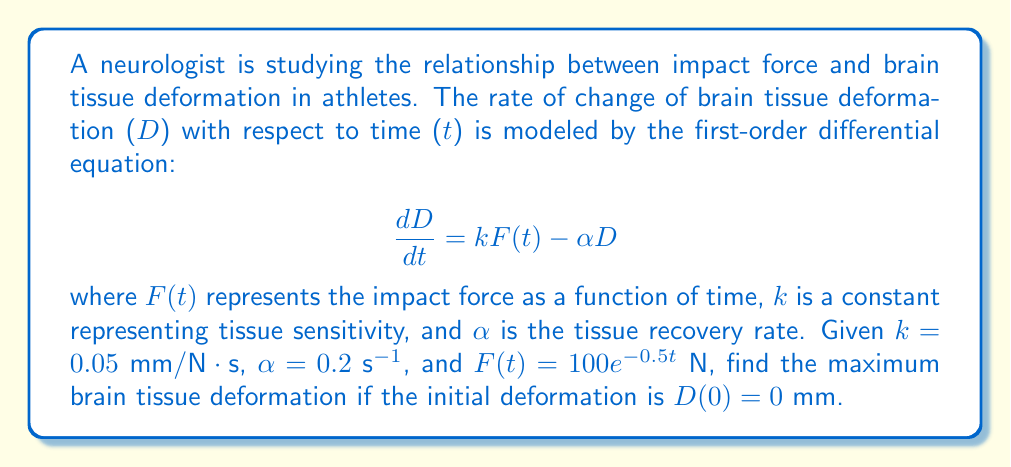Could you help me with this problem? To solve this problem, we need to follow these steps:

1) First, we need to solve the differential equation:

   $$\frac{dD}{dt} = kF(t) - \alpha D$$
   $$\frac{dD}{dt} = 0.05(100e^{-0.5t}) - 0.2D$$
   $$\frac{dD}{dt} = 5e^{-0.5t} - 0.2D$$

2) This is a first-order linear differential equation. The general solution is:

   $$D(t) = e^{-\alpha t}(\int e^{\alpha t}kF(t)dt + C)$$

3) Substituting the values:

   $$D(t) = e^{-0.2t}(\int e^{0.2t}5e^{-0.5t}dt + C)$$
   $$= e^{-0.2t}(\int 5e^{-0.3t}dt + C)$$
   $$= e^{-0.2t}(-\frac{5}{0.3}e^{-0.3t} + C)$$
   $$= -\frac{50}{3}e^{-0.5t} + Ce^{-0.2t}$$

4) Using the initial condition $D(0) = 0$:

   $$0 = -\frac{50}{3} + C$$
   $$C = \frac{50}{3}$$

5) Therefore, the particular solution is:

   $$D(t) = -\frac{50}{3}e^{-0.5t} + \frac{50}{3}e^{-0.2t}$$

6) To find the maximum deformation, we need to find where $\frac{dD}{dt} = 0$:

   $$\frac{dD}{dt} = \frac{25}{3}e^{-0.5t} - \frac{10}{3}e^{-0.2t}$$

7) Setting this equal to zero:

   $$\frac{25}{3}e^{-0.5t} - \frac{10}{3}e^{-0.2t} = 0$$
   $$\frac{25}{3}e^{-0.5t} = \frac{10}{3}e^{-0.2t}$$
   $$\frac{5}{2} = e^{0.3t}$$
   $$\ln(\frac{5}{2}) = 0.3t$$
   $$t = \frac{\ln(\frac{5}{2})}{0.3} \approx 3.054$$

8) The maximum deformation occurs at this time. Substituting this back into our solution:

   $$D(3.054) = -\frac{50}{3}e^{-0.5(3.054)} + \frac{50}{3}e^{-0.2(3.054)} \approx 8.333$$

Therefore, the maximum brain tissue deformation is approximately 8.333 mm.
Answer: The maximum brain tissue deformation is approximately 8.333 mm. 